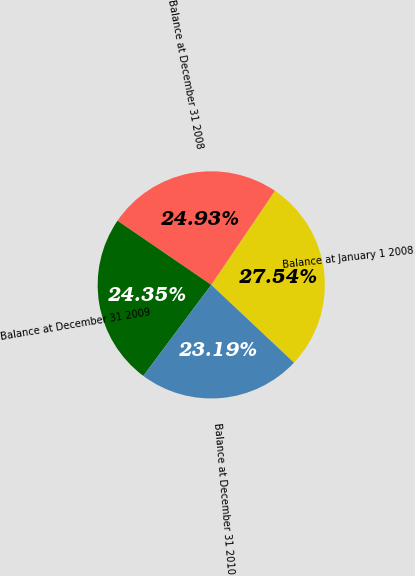<chart> <loc_0><loc_0><loc_500><loc_500><pie_chart><fcel>Balance at January 1 2008<fcel>Balance at December 31 2008<fcel>Balance at December 31 2009<fcel>Balance at December 31 2010<nl><fcel>27.54%<fcel>24.93%<fcel>24.35%<fcel>23.19%<nl></chart> 